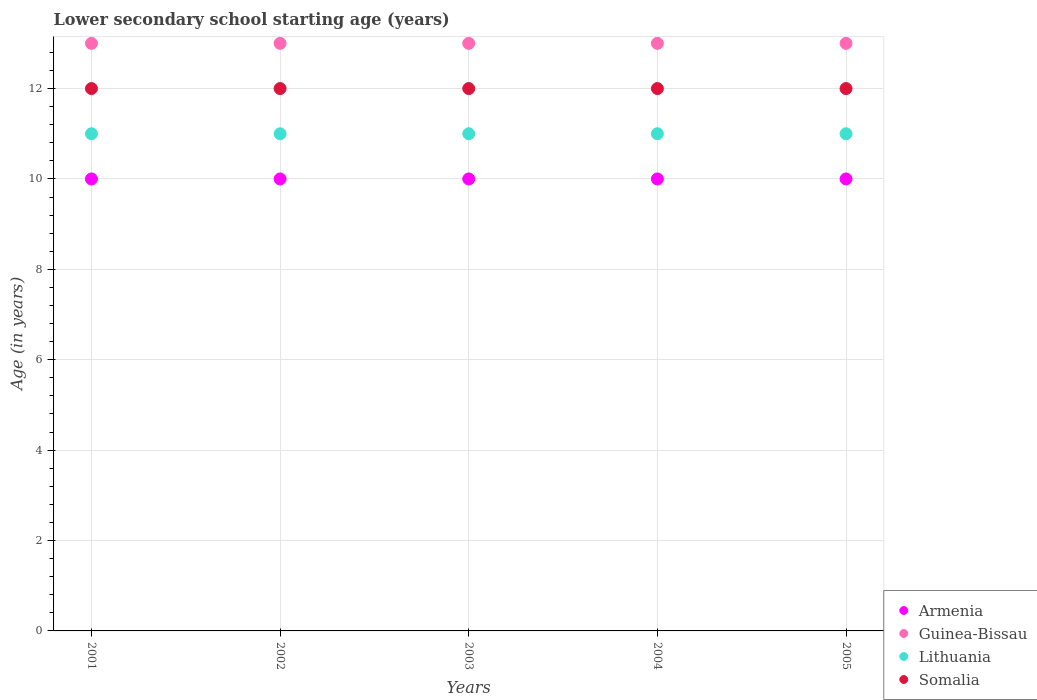Is the number of dotlines equal to the number of legend labels?
Your answer should be compact. Yes. Across all years, what is the maximum lower secondary school starting age of children in Lithuania?
Provide a short and direct response. 11. Across all years, what is the minimum lower secondary school starting age of children in Guinea-Bissau?
Give a very brief answer. 13. In which year was the lower secondary school starting age of children in Lithuania maximum?
Give a very brief answer. 2001. What is the total lower secondary school starting age of children in Armenia in the graph?
Provide a short and direct response. 50. What is the difference between the lower secondary school starting age of children in Armenia in 2002 and that in 2004?
Your answer should be very brief. 0. In the year 2004, what is the difference between the lower secondary school starting age of children in Somalia and lower secondary school starting age of children in Armenia?
Ensure brevity in your answer.  2. What is the difference between the highest and the second highest lower secondary school starting age of children in Somalia?
Your response must be concise. 0. What is the difference between the highest and the lowest lower secondary school starting age of children in Guinea-Bissau?
Your response must be concise. 0. In how many years, is the lower secondary school starting age of children in Armenia greater than the average lower secondary school starting age of children in Armenia taken over all years?
Offer a terse response. 0. Is the sum of the lower secondary school starting age of children in Lithuania in 2003 and 2005 greater than the maximum lower secondary school starting age of children in Armenia across all years?
Provide a short and direct response. Yes. Is it the case that in every year, the sum of the lower secondary school starting age of children in Armenia and lower secondary school starting age of children in Guinea-Bissau  is greater than the sum of lower secondary school starting age of children in Somalia and lower secondary school starting age of children in Lithuania?
Your response must be concise. Yes. Does the lower secondary school starting age of children in Lithuania monotonically increase over the years?
Provide a succinct answer. No. Is the lower secondary school starting age of children in Guinea-Bissau strictly less than the lower secondary school starting age of children in Lithuania over the years?
Keep it short and to the point. No. How many dotlines are there?
Provide a succinct answer. 4. What is the difference between two consecutive major ticks on the Y-axis?
Ensure brevity in your answer.  2. Does the graph contain grids?
Your answer should be compact. Yes. Where does the legend appear in the graph?
Your response must be concise. Bottom right. How many legend labels are there?
Offer a terse response. 4. How are the legend labels stacked?
Ensure brevity in your answer.  Vertical. What is the title of the graph?
Keep it short and to the point. Lower secondary school starting age (years). Does "Seychelles" appear as one of the legend labels in the graph?
Make the answer very short. No. What is the label or title of the Y-axis?
Your response must be concise. Age (in years). What is the Age (in years) of Armenia in 2001?
Provide a short and direct response. 10. What is the Age (in years) in Guinea-Bissau in 2001?
Provide a succinct answer. 13. What is the Age (in years) in Somalia in 2001?
Give a very brief answer. 12. What is the Age (in years) in Guinea-Bissau in 2002?
Your response must be concise. 13. What is the Age (in years) of Lithuania in 2002?
Make the answer very short. 11. What is the Age (in years) in Armenia in 2004?
Offer a terse response. 10. What is the Age (in years) in Guinea-Bissau in 2004?
Provide a succinct answer. 13. What is the Age (in years) of Somalia in 2004?
Give a very brief answer. 12. What is the Age (in years) of Guinea-Bissau in 2005?
Your answer should be compact. 13. Across all years, what is the maximum Age (in years) of Armenia?
Offer a terse response. 10. Across all years, what is the maximum Age (in years) of Lithuania?
Provide a short and direct response. 11. Across all years, what is the minimum Age (in years) in Somalia?
Offer a very short reply. 12. What is the difference between the Age (in years) in Somalia in 2001 and that in 2002?
Provide a short and direct response. 0. What is the difference between the Age (in years) of Lithuania in 2001 and that in 2003?
Your response must be concise. 0. What is the difference between the Age (in years) of Lithuania in 2001 and that in 2004?
Keep it short and to the point. 0. What is the difference between the Age (in years) in Somalia in 2001 and that in 2004?
Give a very brief answer. 0. What is the difference between the Age (in years) of Guinea-Bissau in 2001 and that in 2005?
Ensure brevity in your answer.  0. What is the difference between the Age (in years) in Lithuania in 2001 and that in 2005?
Make the answer very short. 0. What is the difference between the Age (in years) in Armenia in 2002 and that in 2003?
Provide a succinct answer. 0. What is the difference between the Age (in years) in Armenia in 2002 and that in 2004?
Give a very brief answer. 0. What is the difference between the Age (in years) in Guinea-Bissau in 2002 and that in 2004?
Your answer should be compact. 0. What is the difference between the Age (in years) of Lithuania in 2002 and that in 2004?
Offer a terse response. 0. What is the difference between the Age (in years) of Somalia in 2002 and that in 2004?
Keep it short and to the point. 0. What is the difference between the Age (in years) of Guinea-Bissau in 2002 and that in 2005?
Give a very brief answer. 0. What is the difference between the Age (in years) of Somalia in 2002 and that in 2005?
Make the answer very short. 0. What is the difference between the Age (in years) of Armenia in 2003 and that in 2004?
Offer a terse response. 0. What is the difference between the Age (in years) in Lithuania in 2003 and that in 2004?
Ensure brevity in your answer.  0. What is the difference between the Age (in years) of Somalia in 2003 and that in 2004?
Keep it short and to the point. 0. What is the difference between the Age (in years) of Lithuania in 2003 and that in 2005?
Your answer should be compact. 0. What is the difference between the Age (in years) in Somalia in 2003 and that in 2005?
Your response must be concise. 0. What is the difference between the Age (in years) of Lithuania in 2004 and that in 2005?
Your answer should be very brief. 0. What is the difference between the Age (in years) of Somalia in 2004 and that in 2005?
Make the answer very short. 0. What is the difference between the Age (in years) of Armenia in 2001 and the Age (in years) of Guinea-Bissau in 2002?
Give a very brief answer. -3. What is the difference between the Age (in years) of Armenia in 2001 and the Age (in years) of Lithuania in 2002?
Make the answer very short. -1. What is the difference between the Age (in years) in Guinea-Bissau in 2001 and the Age (in years) in Somalia in 2002?
Offer a terse response. 1. What is the difference between the Age (in years) of Lithuania in 2001 and the Age (in years) of Somalia in 2002?
Give a very brief answer. -1. What is the difference between the Age (in years) in Armenia in 2001 and the Age (in years) in Somalia in 2003?
Provide a short and direct response. -2. What is the difference between the Age (in years) of Guinea-Bissau in 2001 and the Age (in years) of Lithuania in 2003?
Give a very brief answer. 2. What is the difference between the Age (in years) of Guinea-Bissau in 2001 and the Age (in years) of Somalia in 2003?
Ensure brevity in your answer.  1. What is the difference between the Age (in years) of Armenia in 2001 and the Age (in years) of Somalia in 2004?
Make the answer very short. -2. What is the difference between the Age (in years) in Armenia in 2002 and the Age (in years) in Lithuania in 2003?
Your answer should be very brief. -1. What is the difference between the Age (in years) of Guinea-Bissau in 2002 and the Age (in years) of Somalia in 2003?
Provide a short and direct response. 1. What is the difference between the Age (in years) of Armenia in 2002 and the Age (in years) of Somalia in 2004?
Your answer should be compact. -2. What is the difference between the Age (in years) in Guinea-Bissau in 2002 and the Age (in years) in Lithuania in 2004?
Offer a very short reply. 2. What is the difference between the Age (in years) of Lithuania in 2002 and the Age (in years) of Somalia in 2004?
Your response must be concise. -1. What is the difference between the Age (in years) of Guinea-Bissau in 2002 and the Age (in years) of Somalia in 2005?
Your response must be concise. 1. What is the difference between the Age (in years) of Lithuania in 2002 and the Age (in years) of Somalia in 2005?
Provide a short and direct response. -1. What is the difference between the Age (in years) of Armenia in 2003 and the Age (in years) of Guinea-Bissau in 2004?
Your answer should be compact. -3. What is the difference between the Age (in years) of Guinea-Bissau in 2003 and the Age (in years) of Lithuania in 2004?
Your response must be concise. 2. What is the difference between the Age (in years) of Lithuania in 2003 and the Age (in years) of Somalia in 2004?
Provide a succinct answer. -1. What is the difference between the Age (in years) of Armenia in 2003 and the Age (in years) of Lithuania in 2005?
Your answer should be very brief. -1. What is the difference between the Age (in years) in Guinea-Bissau in 2003 and the Age (in years) in Lithuania in 2005?
Offer a very short reply. 2. What is the difference between the Age (in years) in Guinea-Bissau in 2003 and the Age (in years) in Somalia in 2005?
Your response must be concise. 1. What is the difference between the Age (in years) of Armenia in 2004 and the Age (in years) of Lithuania in 2005?
Your answer should be compact. -1. What is the difference between the Age (in years) of Armenia in 2004 and the Age (in years) of Somalia in 2005?
Provide a short and direct response. -2. What is the difference between the Age (in years) in Guinea-Bissau in 2004 and the Age (in years) in Lithuania in 2005?
Your answer should be very brief. 2. What is the difference between the Age (in years) in Guinea-Bissau in 2004 and the Age (in years) in Somalia in 2005?
Make the answer very short. 1. What is the average Age (in years) of Armenia per year?
Provide a succinct answer. 10. What is the average Age (in years) of Guinea-Bissau per year?
Offer a terse response. 13. What is the average Age (in years) of Somalia per year?
Keep it short and to the point. 12. In the year 2001, what is the difference between the Age (in years) in Armenia and Age (in years) in Guinea-Bissau?
Keep it short and to the point. -3. In the year 2001, what is the difference between the Age (in years) in Armenia and Age (in years) in Lithuania?
Make the answer very short. -1. In the year 2001, what is the difference between the Age (in years) in Armenia and Age (in years) in Somalia?
Your answer should be very brief. -2. In the year 2001, what is the difference between the Age (in years) of Guinea-Bissau and Age (in years) of Somalia?
Provide a succinct answer. 1. In the year 2002, what is the difference between the Age (in years) in Armenia and Age (in years) in Guinea-Bissau?
Offer a very short reply. -3. In the year 2002, what is the difference between the Age (in years) of Guinea-Bissau and Age (in years) of Somalia?
Keep it short and to the point. 1. In the year 2003, what is the difference between the Age (in years) in Armenia and Age (in years) in Guinea-Bissau?
Offer a terse response. -3. In the year 2003, what is the difference between the Age (in years) of Armenia and Age (in years) of Lithuania?
Ensure brevity in your answer.  -1. In the year 2003, what is the difference between the Age (in years) of Guinea-Bissau and Age (in years) of Lithuania?
Provide a succinct answer. 2. In the year 2004, what is the difference between the Age (in years) in Armenia and Age (in years) in Somalia?
Keep it short and to the point. -2. In the year 2004, what is the difference between the Age (in years) in Guinea-Bissau and Age (in years) in Lithuania?
Your answer should be compact. 2. In the year 2004, what is the difference between the Age (in years) in Lithuania and Age (in years) in Somalia?
Give a very brief answer. -1. In the year 2005, what is the difference between the Age (in years) in Armenia and Age (in years) in Somalia?
Provide a succinct answer. -2. In the year 2005, what is the difference between the Age (in years) of Guinea-Bissau and Age (in years) of Somalia?
Offer a very short reply. 1. In the year 2005, what is the difference between the Age (in years) of Lithuania and Age (in years) of Somalia?
Your answer should be very brief. -1. What is the ratio of the Age (in years) of Guinea-Bissau in 2001 to that in 2002?
Offer a very short reply. 1. What is the ratio of the Age (in years) of Lithuania in 2001 to that in 2002?
Provide a succinct answer. 1. What is the ratio of the Age (in years) of Somalia in 2001 to that in 2002?
Give a very brief answer. 1. What is the ratio of the Age (in years) in Armenia in 2001 to that in 2003?
Give a very brief answer. 1. What is the ratio of the Age (in years) in Somalia in 2001 to that in 2004?
Your answer should be very brief. 1. What is the ratio of the Age (in years) in Armenia in 2001 to that in 2005?
Make the answer very short. 1. What is the ratio of the Age (in years) in Guinea-Bissau in 2001 to that in 2005?
Provide a succinct answer. 1. What is the ratio of the Age (in years) of Lithuania in 2001 to that in 2005?
Your answer should be very brief. 1. What is the ratio of the Age (in years) in Guinea-Bissau in 2002 to that in 2003?
Provide a succinct answer. 1. What is the ratio of the Age (in years) of Lithuania in 2002 to that in 2003?
Provide a succinct answer. 1. What is the ratio of the Age (in years) of Somalia in 2002 to that in 2003?
Make the answer very short. 1. What is the ratio of the Age (in years) in Guinea-Bissau in 2002 to that in 2004?
Your answer should be compact. 1. What is the ratio of the Age (in years) in Lithuania in 2002 to that in 2004?
Offer a terse response. 1. What is the ratio of the Age (in years) of Guinea-Bissau in 2002 to that in 2005?
Give a very brief answer. 1. What is the ratio of the Age (in years) of Armenia in 2003 to that in 2004?
Offer a terse response. 1. What is the ratio of the Age (in years) of Lithuania in 2003 to that in 2004?
Provide a short and direct response. 1. What is the ratio of the Age (in years) of Somalia in 2003 to that in 2004?
Provide a succinct answer. 1. What is the ratio of the Age (in years) of Guinea-Bissau in 2003 to that in 2005?
Provide a succinct answer. 1. What is the ratio of the Age (in years) in Lithuania in 2003 to that in 2005?
Your answer should be compact. 1. What is the ratio of the Age (in years) of Armenia in 2004 to that in 2005?
Offer a very short reply. 1. What is the ratio of the Age (in years) in Guinea-Bissau in 2004 to that in 2005?
Make the answer very short. 1. What is the ratio of the Age (in years) of Lithuania in 2004 to that in 2005?
Give a very brief answer. 1. What is the ratio of the Age (in years) of Somalia in 2004 to that in 2005?
Your answer should be compact. 1. What is the difference between the highest and the second highest Age (in years) of Lithuania?
Ensure brevity in your answer.  0. What is the difference between the highest and the lowest Age (in years) in Lithuania?
Offer a very short reply. 0. 